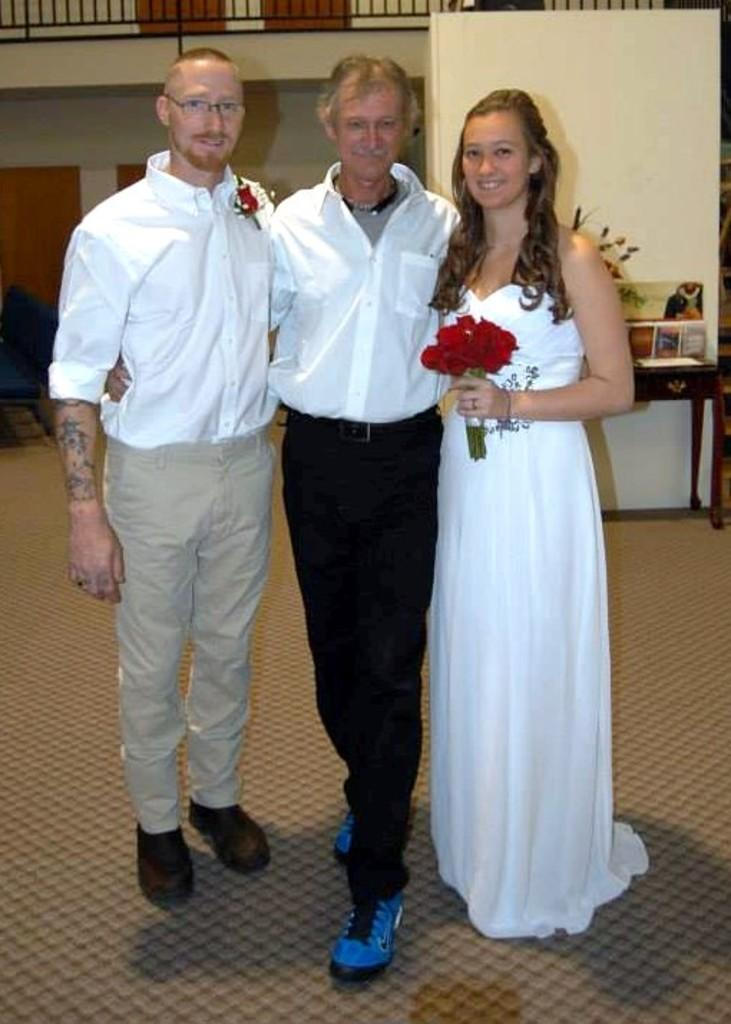How many people are in the image? There are three persons standing on the floor in the image. What is one of the persons holding? One of the persons is holding a flower bouquet with her hand. What can be seen in the background of the image? There is a wall, a table, and frames in the background of the image. What type of growth can be seen on the wall in the image? There is no visible growth on the wall in the image. Is there any indication of rain in the image? There is no indication of rain in the image. 